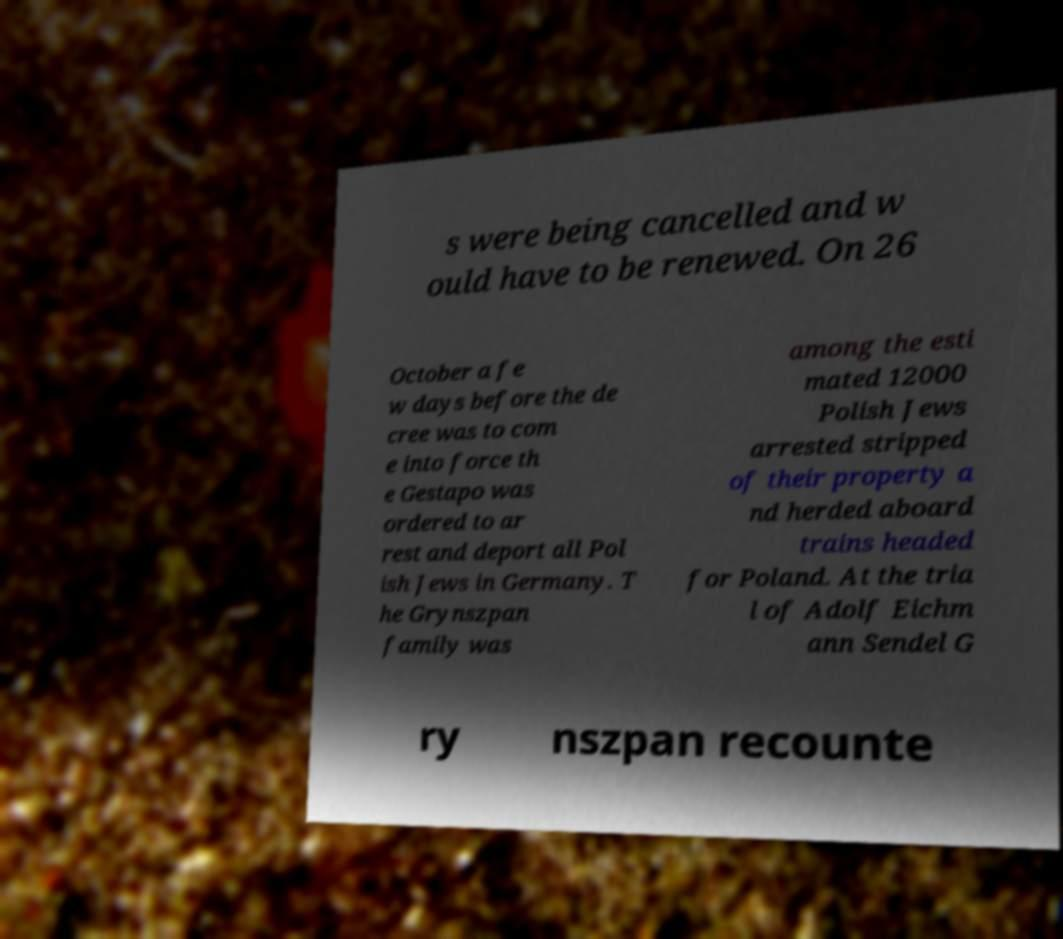I need the written content from this picture converted into text. Can you do that? s were being cancelled and w ould have to be renewed. On 26 October a fe w days before the de cree was to com e into force th e Gestapo was ordered to ar rest and deport all Pol ish Jews in Germany. T he Grynszpan family was among the esti mated 12000 Polish Jews arrested stripped of their property a nd herded aboard trains headed for Poland. At the tria l of Adolf Eichm ann Sendel G ry nszpan recounte 